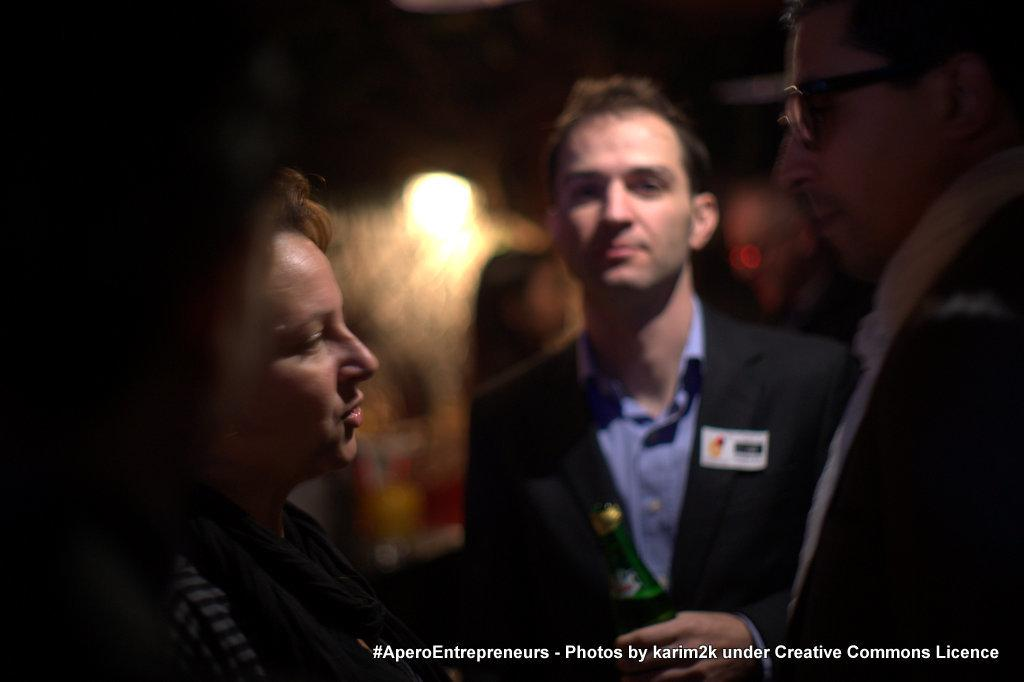What are the people in the image wearing? The people in the image are wearing dresses. What can be seen illuminating the scene in the image? There are lights visible in the image. What color is the background of the image? The background of the image is black. What is present on the image besides the people and lights? There is text or writing on the image. Can you see any cobwebs in the image? There are no cobwebs present in the image. What type of ship can be seen in the image? There is no ship present in the image. 